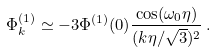<formula> <loc_0><loc_0><loc_500><loc_500>\Phi _ { k } ^ { ( 1 ) } \simeq - 3 \Phi ^ { ( 1 ) } ( 0 ) \frac { \cos ( \omega _ { 0 } \eta ) } { ( k \eta / \sqrt { 3 } ) ^ { 2 } } \, .</formula> 